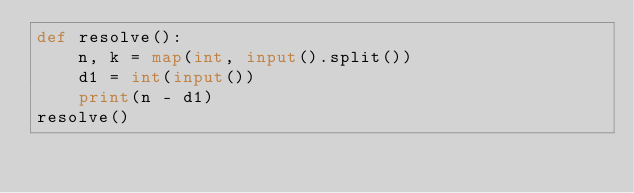Convert code to text. <code><loc_0><loc_0><loc_500><loc_500><_Python_>def resolve():
	n, k = map(int, input().split())
	d1 = int(input())
	print(n - d1)
resolve()</code> 